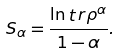Convert formula to latex. <formula><loc_0><loc_0><loc_500><loc_500>S _ { \alpha } = \frac { \ln \mathop t r \rho ^ { \alpha } } { 1 - \alpha } .</formula> 